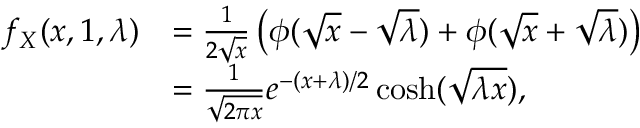<formula> <loc_0><loc_0><loc_500><loc_500>{ \begin{array} { r l } { f _ { X } ( x , 1 , \lambda ) } & { = { \frac { 1 } { 2 { \sqrt { x } } } } \left ( \phi ( { \sqrt { x } } - { \sqrt { \lambda } } ) + \phi ( { \sqrt { x } } + { \sqrt { \lambda } } ) \right ) } \\ & { = { \frac { 1 } { \sqrt { 2 \pi x } } } e ^ { - ( x + \lambda ) / 2 } \cosh ( { \sqrt { \lambda x } } ) , } \end{array} }</formula> 